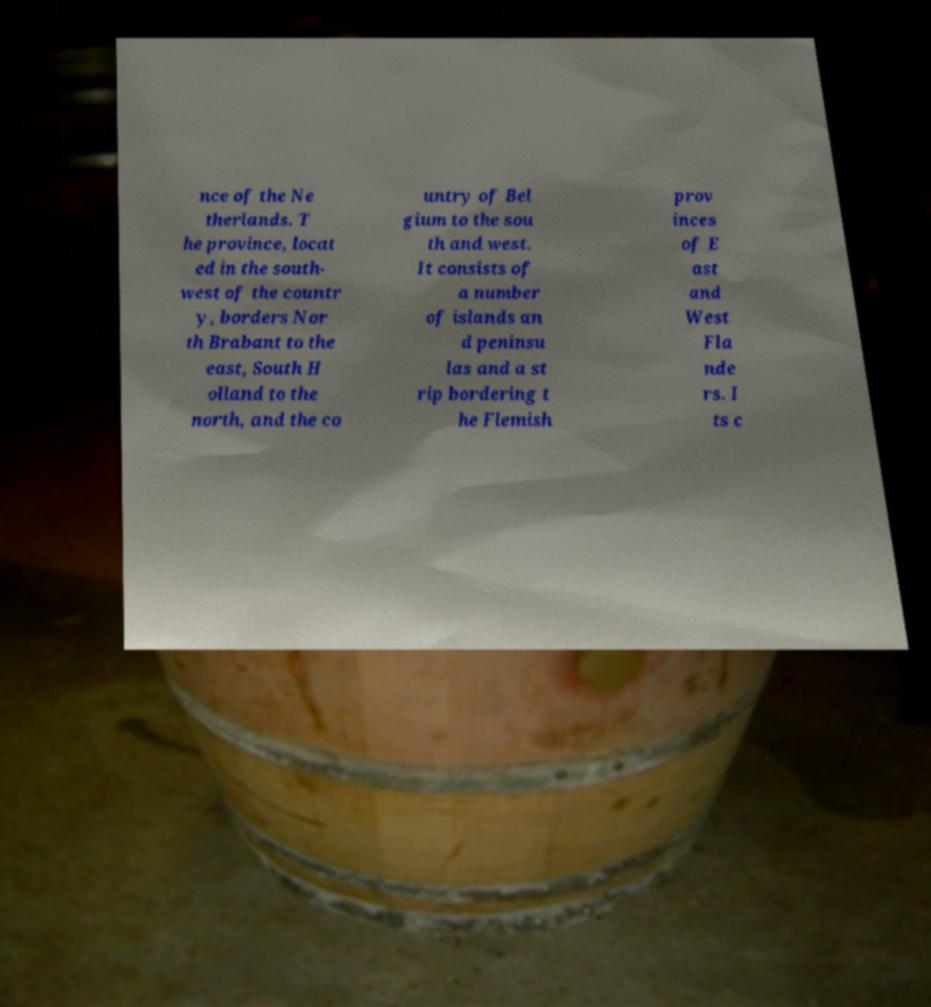What messages or text are displayed in this image? I need them in a readable, typed format. nce of the Ne therlands. T he province, locat ed in the south- west of the countr y, borders Nor th Brabant to the east, South H olland to the north, and the co untry of Bel gium to the sou th and west. It consists of a number of islands an d peninsu las and a st rip bordering t he Flemish prov inces of E ast and West Fla nde rs. I ts c 